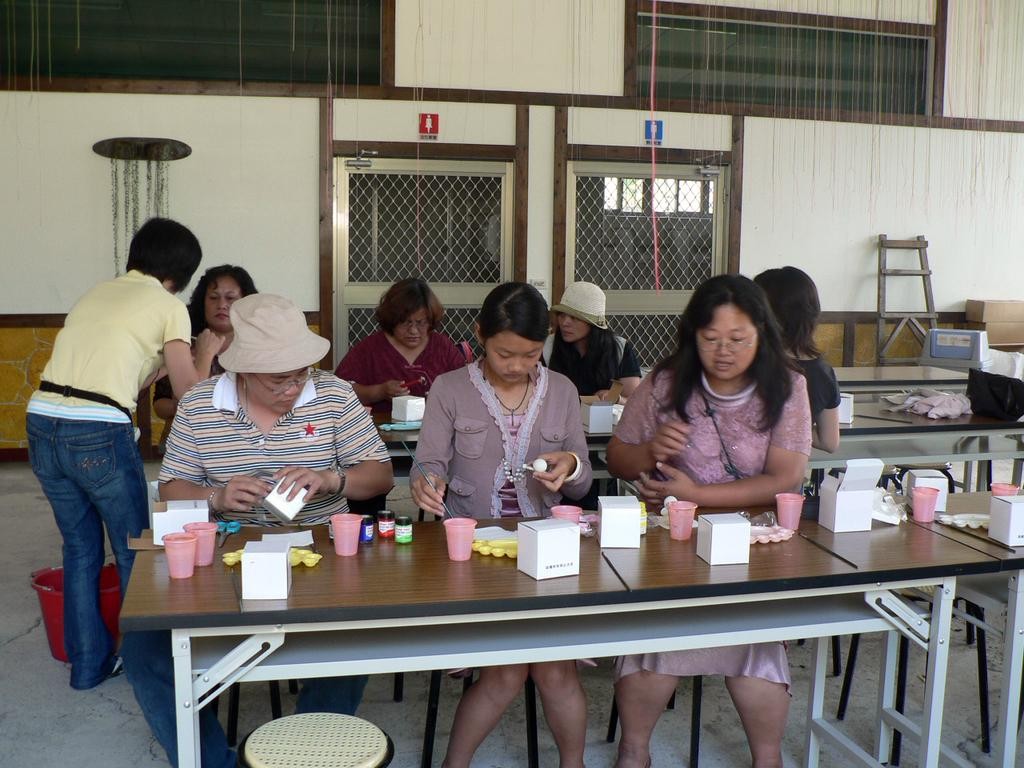What is the main subject of the image? The main subject of the image is a group of people. What are the people in the image doing? The people are sitting and working. Can you see any mice running around the people in the image? There are no mice present in the image. Is there any smoke visible in the image? There is no smoke visible in the image. What type of stem is growing from the people's heads in the image? There are no stems growing from the people's heads in the image. 